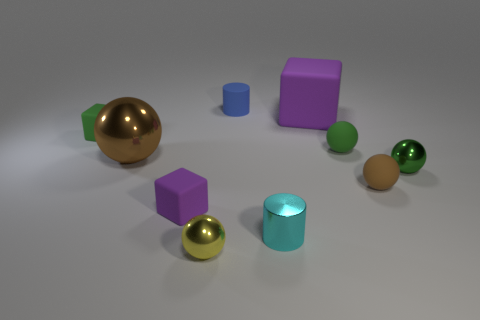There is a cyan metallic thing that is the same size as the yellow shiny thing; what shape is it?
Keep it short and to the point. Cylinder. What number of tiny blocks have the same color as the large matte thing?
Make the answer very short. 1. Is the tiny block that is in front of the big brown ball made of the same material as the tiny brown thing?
Make the answer very short. Yes. There is a tiny green metallic object; what shape is it?
Provide a succinct answer. Sphere. What number of cyan things are tiny metal cylinders or spheres?
Your answer should be very brief. 1. What number of other objects are the same material as the blue object?
Keep it short and to the point. 5. Does the purple rubber object on the right side of the blue matte cylinder have the same shape as the tiny cyan metallic object?
Offer a very short reply. No. Are there any blue cylinders?
Offer a terse response. Yes. Are there more things on the left side of the small blue matte thing than metallic objects?
Give a very brief answer. No. Are there any tiny green things left of the tiny yellow shiny object?
Ensure brevity in your answer.  Yes. 